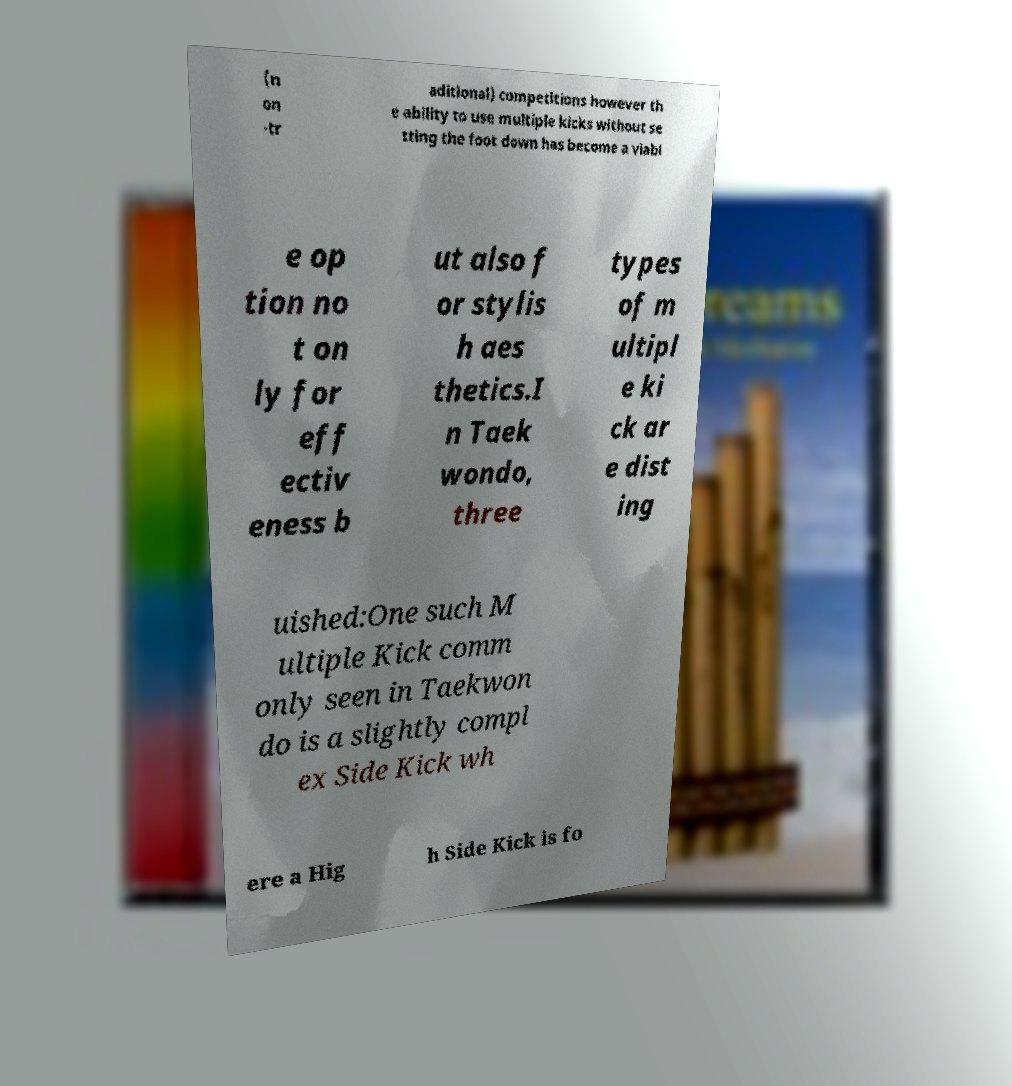What messages or text are displayed in this image? I need them in a readable, typed format. (n on -tr aditional) competitions however th e ability to use multiple kicks without se tting the foot down has become a viabl e op tion no t on ly for eff ectiv eness b ut also f or stylis h aes thetics.I n Taek wondo, three types of m ultipl e ki ck ar e dist ing uished:One such M ultiple Kick comm only seen in Taekwon do is a slightly compl ex Side Kick wh ere a Hig h Side Kick is fo 